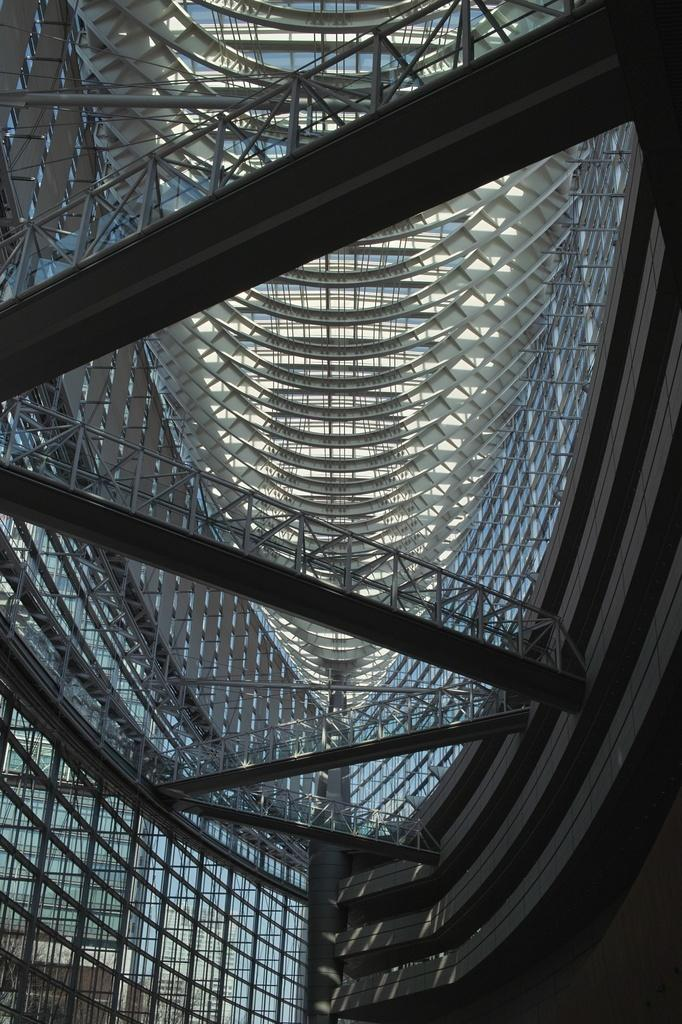What type of structure is present in the image? There is a building in the image. What is the uppermost part of the building? The building has a roof. What feature can be seen on the roof? The roof has a railing. What type of tramp can be seen jumping over the building in the image? There is no tramp present in the image, nor is there any indication of someone jumping over the building. 